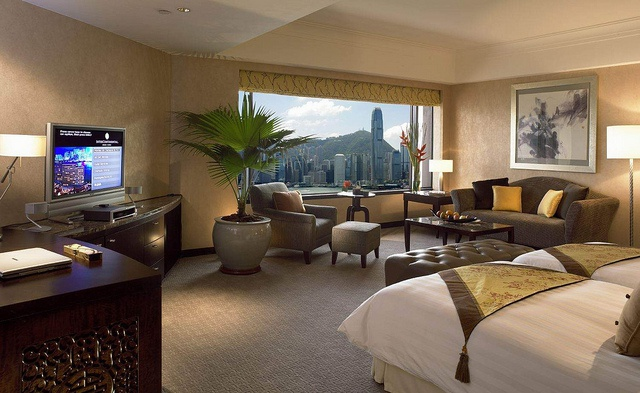Describe the objects in this image and their specific colors. I can see bed in gray, tan, and darkgray tones, potted plant in gray, black, and darkgreen tones, couch in gray, black, maroon, and olive tones, tv in gray, black, lavender, and darkgray tones, and chair in gray, black, and darkgray tones in this image. 